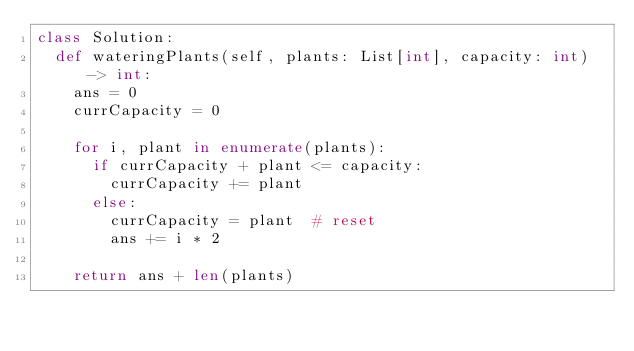<code> <loc_0><loc_0><loc_500><loc_500><_Python_>class Solution:
  def wateringPlants(self, plants: List[int], capacity: int) -> int:
    ans = 0
    currCapacity = 0

    for i, plant in enumerate(plants):
      if currCapacity + plant <= capacity:
        currCapacity += plant
      else:
        currCapacity = plant  # reset
        ans += i * 2

    return ans + len(plants)
</code> 